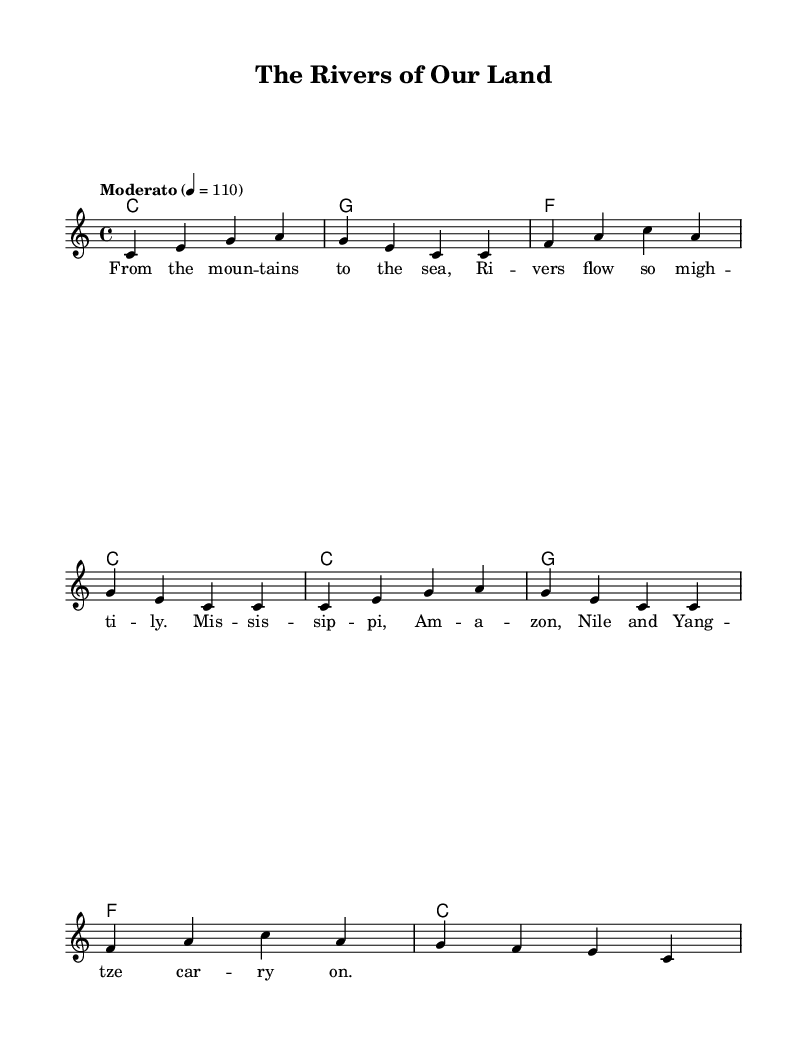What is the key signature of this music? The key signature is C major, which has no sharps or flats.
Answer: C major What is the time signature of this music? The time signature is 4/4, indicating that there are four beats per measure, and the quarter note gets one beat.
Answer: 4/4 What is the tempo marking of this music? The tempo marking is "Moderato," which indicates a moderate speed for the music, specifically at 110 beats per minute.
Answer: Moderato How many measures are in the melody? There are eight measures in the melody, as counted by the bar lines separating the notes.
Answer: 8 Which rivers are mentioned in the lyrics? The lyrics mention the Mississippi, Amazon, Nile, and Yangtze rivers, all of which are significant in history and geography.
Answer: Mississippi, Amazon, Nile, Yangtze What is the role of the harmonies in this piece? The harmonies provide accompaniment in chord form, supporting the melody and adding depth to the overall sound by playing chords in a rhythmic pattern.
Answer: Chord accompaniment How might this song teach about geography? The song teaches about geography by naming major rivers, which can help listeners learn the locations and importance of these geographical features.
Answer: By naming major rivers 